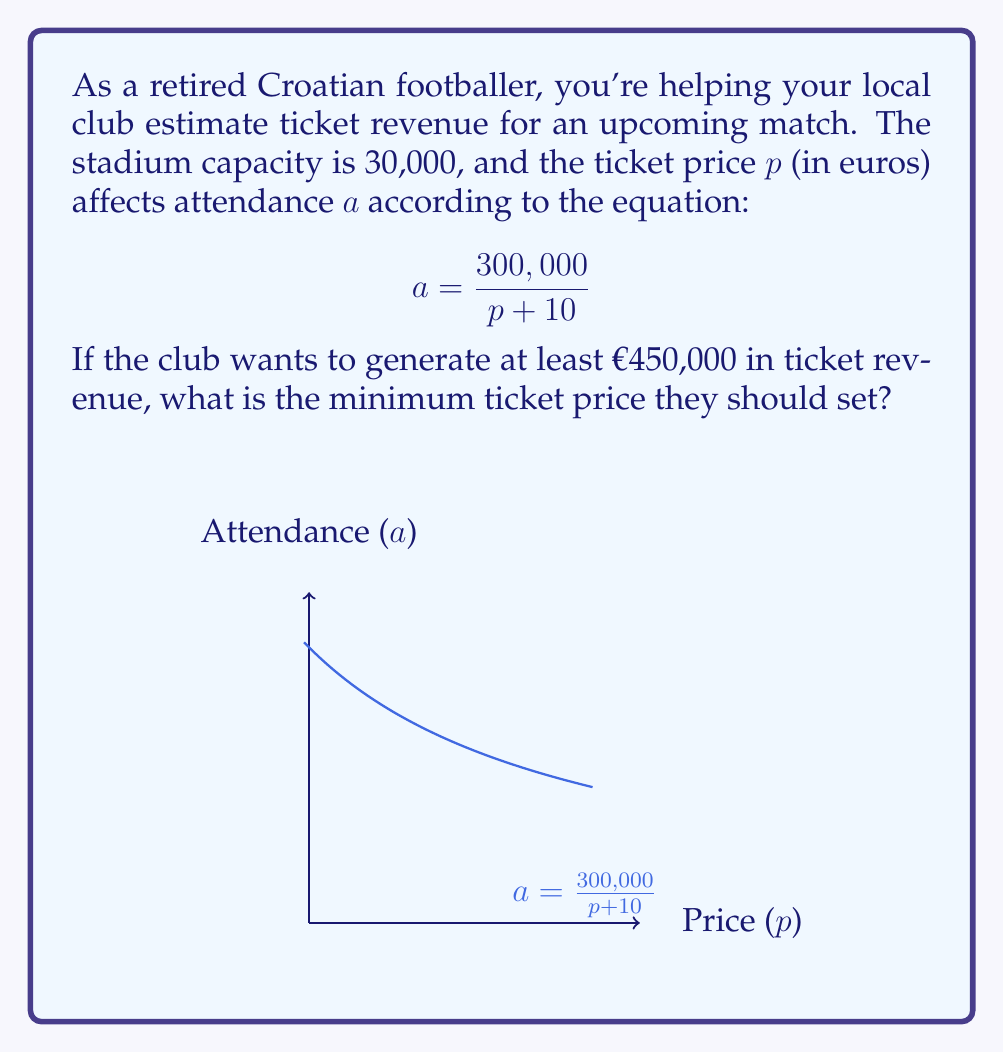Show me your answer to this math problem. Let's approach this step-by-step:

1) The revenue $R$ is the product of attendance $a$ and price $p$:
   $$R = a \cdot p$$

2) Substitute the attendance equation:
   $$R = \frac{300,000}{p + 10} \cdot p$$

3) Simplify:
   $$R = \frac{300,000p}{p + 10}$$

4) We want $R$ to be at least 450,000:
   $$\frac{300,000p}{p + 10} \geq 450,000$$

5) Multiply both sides by $(p + 10)$:
   $$300,000p \geq 450,000(p + 10)$$

6) Expand the right side:
   $$300,000p \geq 450,000p + 4,500,000$$

7) Subtract $450,000p$ from both sides:
   $$-150,000p \geq 4,500,000$$

8) Divide both sides by -150,000 (and flip the inequality sign):
   $$p \leq -30$$

9) Since price can't be negative, we need the next integer above -30.

Therefore, the minimum ticket price should be €31.
Answer: €31 